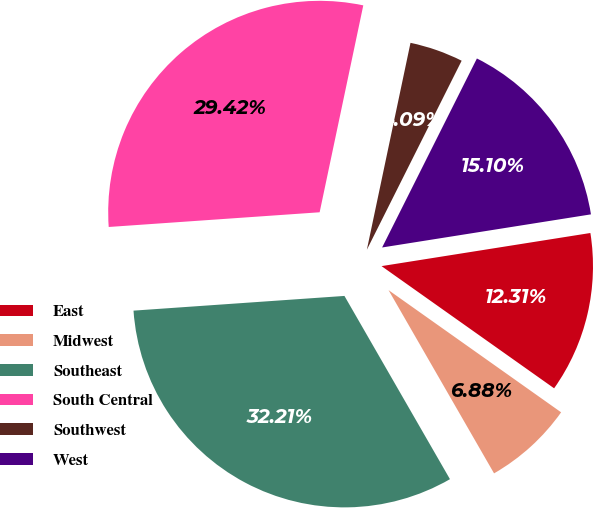<chart> <loc_0><loc_0><loc_500><loc_500><pie_chart><fcel>East<fcel>Midwest<fcel>Southeast<fcel>South Central<fcel>Southwest<fcel>West<nl><fcel>12.31%<fcel>6.88%<fcel>32.21%<fcel>29.42%<fcel>4.09%<fcel>15.1%<nl></chart> 